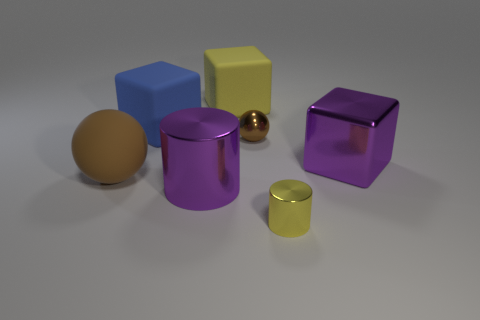What number of blocks have the same size as the yellow rubber thing?
Make the answer very short. 2. Is the number of big matte spheres that are on the left side of the large brown sphere greater than the number of small yellow metallic cylinders to the right of the purple cube?
Give a very brief answer. No. Are there any big blue objects that have the same shape as the yellow shiny thing?
Make the answer very short. No. What size is the matte object to the right of the large purple object to the left of the tiny brown sphere?
Your answer should be compact. Large. What shape is the purple thing that is right of the brown sphere that is behind the large metal thing that is behind the brown rubber thing?
Your answer should be compact. Cube. What size is the brown sphere that is made of the same material as the large cylinder?
Your answer should be very brief. Small. Is the number of big yellow objects greater than the number of small shiny objects?
Your answer should be compact. No. What material is the brown thing that is the same size as the yellow shiny object?
Offer a terse response. Metal. Is the size of the cube that is on the left side of the yellow rubber block the same as the matte sphere?
Keep it short and to the point. Yes. What number of cylinders are either yellow metallic things or green rubber objects?
Provide a succinct answer. 1. 